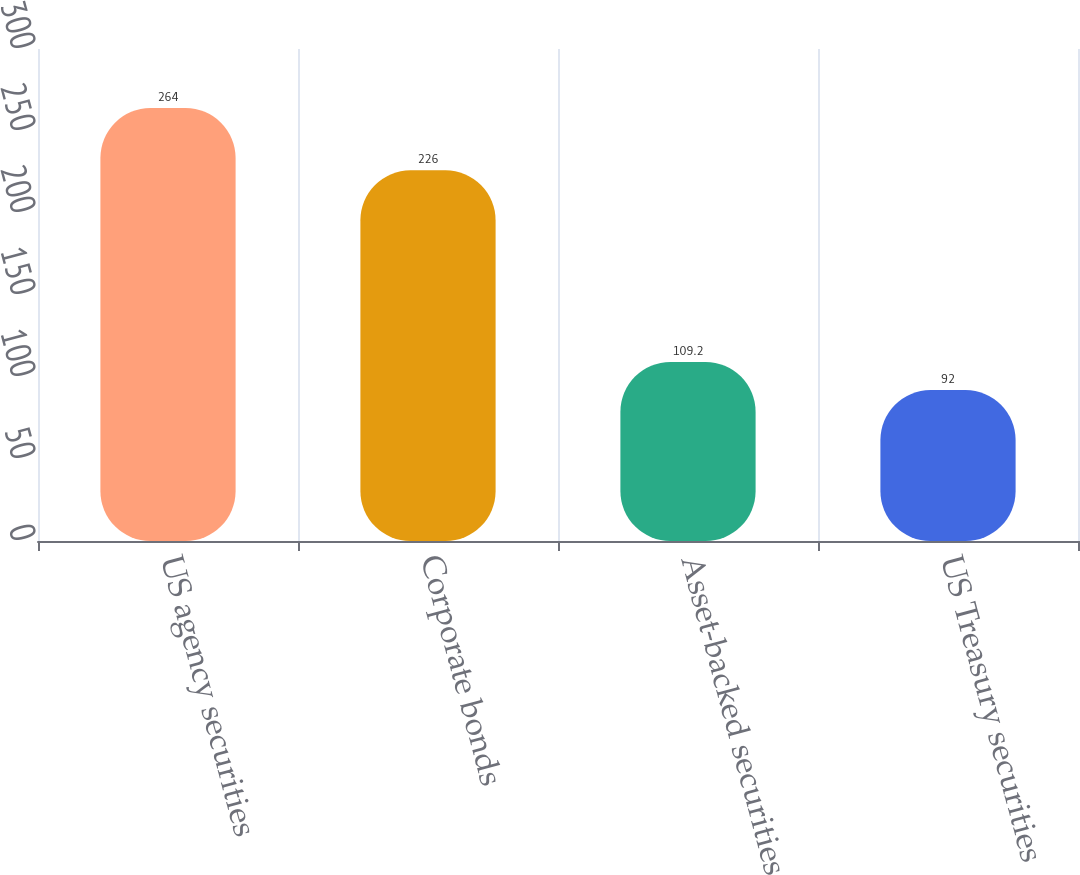Convert chart. <chart><loc_0><loc_0><loc_500><loc_500><bar_chart><fcel>US agency securities<fcel>Corporate bonds<fcel>Asset-backed securities<fcel>US Treasury securities<nl><fcel>264<fcel>226<fcel>109.2<fcel>92<nl></chart> 